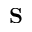Convert formula to latex. <formula><loc_0><loc_0><loc_500><loc_500>S</formula> 